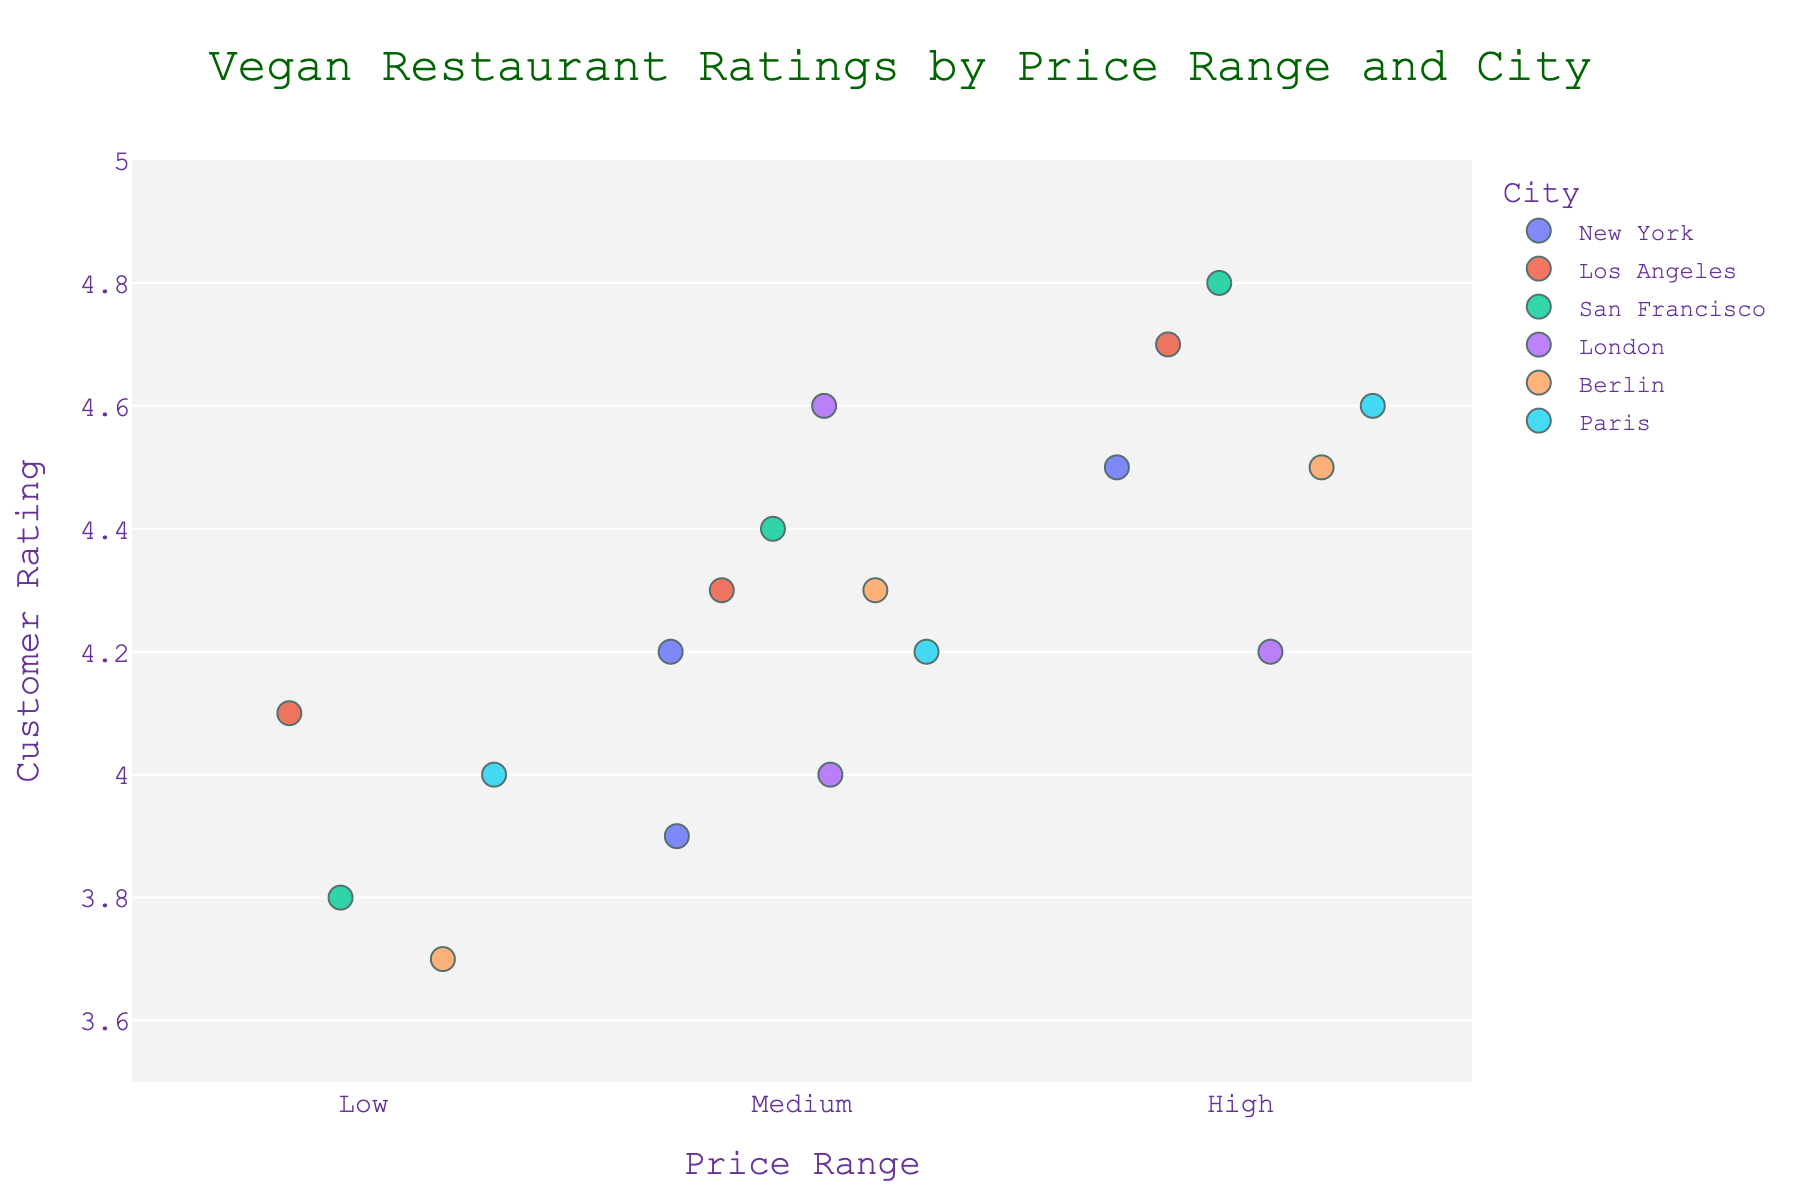What is the title of the plot? The title is usually displayed at the top of the plot. It summarizes what the plot is about.
Answer: Vegan Restaurant Ratings by Price Range and City How many cities are represented in the plot? Each city is represented by a different color in the plot. Count the number of colors.
Answer: 5 Which restaurant has the highest rating, and what city is it located in? Look at the highest point on the y-axis and see which restaurant it is associated with, along with the city color.
Answer: Shizen Vegan Sushi Bar, San Francisco What is the average rating of vegan restaurants in the "High" price range? Add up all the ratings in the "High" price range and divide by the count of those ratings.
Answer: (4.5 + 4.7 + 4.8 + 4.6 + 4.5 + 4.6) / 6 = 4.62 Which city has the most variability in ratings within the "Medium" price range? Look at the spread of the points within the "Medium" price range for each city. The city with the widest spread has the most variability.
Answer: New York How many restaurants are there in the "Low" price range in Los Angeles? Identify the points corresponding to Los Angeles and within the "Low" category on the x-axis. Count them.
Answer: 1 In which price range does Berlin have the lowest average rating? Calculate the average rating for Berlin's restaurants in each price range. Compare these averages.
Answer: Low Which city has a restaurant in each price range (Low, Medium, High)? Check each city and see if there is at least one point in each price range.
Answer: Paris What is the difference in ratings between the highest-rated and lowest-rated restaurants in New York? Identify the highest and lowest rating points for New York and calculate the difference.
Answer: 4.5 - 3.9 = 0.6 